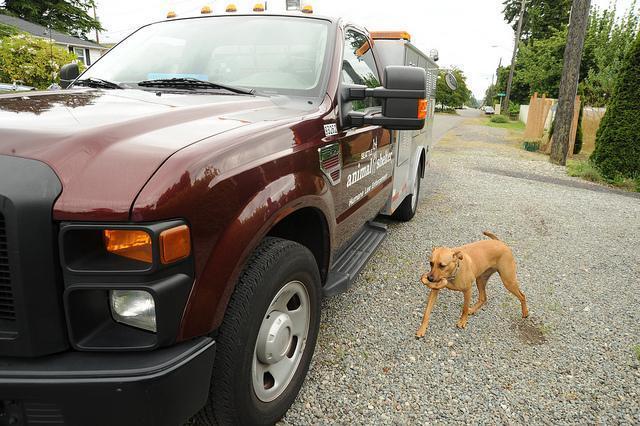How many people are on skateboards?
Give a very brief answer. 0. 